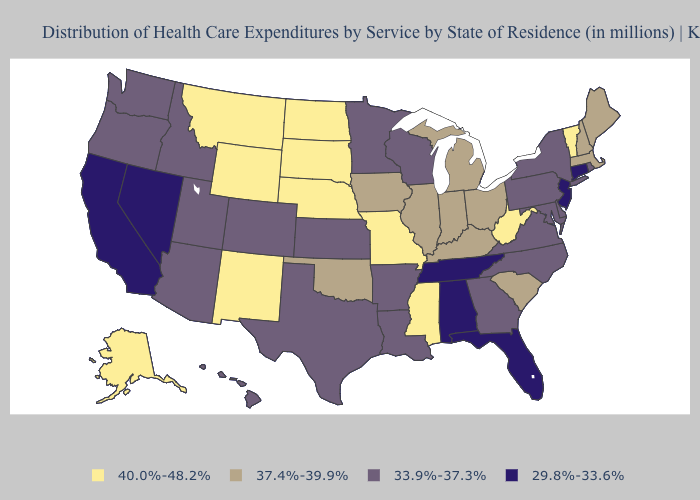What is the highest value in the West ?
Answer briefly. 40.0%-48.2%. Name the states that have a value in the range 33.9%-37.3%?
Write a very short answer. Arizona, Arkansas, Colorado, Delaware, Georgia, Hawaii, Idaho, Kansas, Louisiana, Maryland, Minnesota, New York, North Carolina, Oregon, Pennsylvania, Rhode Island, Texas, Utah, Virginia, Washington, Wisconsin. Name the states that have a value in the range 37.4%-39.9%?
Concise answer only. Illinois, Indiana, Iowa, Kentucky, Maine, Massachusetts, Michigan, New Hampshire, Ohio, Oklahoma, South Carolina. Among the states that border Utah , which have the lowest value?
Short answer required. Nevada. Name the states that have a value in the range 29.8%-33.6%?
Concise answer only. Alabama, California, Connecticut, Florida, Nevada, New Jersey, Tennessee. Which states have the highest value in the USA?
Give a very brief answer. Alaska, Mississippi, Missouri, Montana, Nebraska, New Mexico, North Dakota, South Dakota, Vermont, West Virginia, Wyoming. Name the states that have a value in the range 40.0%-48.2%?
Concise answer only. Alaska, Mississippi, Missouri, Montana, Nebraska, New Mexico, North Dakota, South Dakota, Vermont, West Virginia, Wyoming. What is the value of Oklahoma?
Quick response, please. 37.4%-39.9%. Does Louisiana have a higher value than Florida?
Keep it brief. Yes. What is the value of Nevada?
Answer briefly. 29.8%-33.6%. Name the states that have a value in the range 29.8%-33.6%?
Short answer required. Alabama, California, Connecticut, Florida, Nevada, New Jersey, Tennessee. Among the states that border Vermont , does New Hampshire have the lowest value?
Write a very short answer. No. Does Vermont have the highest value in the Northeast?
Keep it brief. Yes. Does Nebraska have the lowest value in the USA?
Give a very brief answer. No. Does South Carolina have the highest value in the South?
Keep it brief. No. 